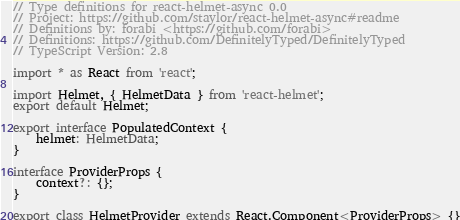<code> <loc_0><loc_0><loc_500><loc_500><_TypeScript_>// Type definitions for react-helmet-async 0.0
// Project: https://github.com/staylor/react-helmet-async#readme
// Definitions by: forabi <https://github.com/forabi>
// Definitions: https://github.com/DefinitelyTyped/DefinitelyTyped
// TypeScript Version: 2.8

import * as React from 'react';

import Helmet, { HelmetData } from 'react-helmet';
export default Helmet;

export interface PopulatedContext {
    helmet: HelmetData;
}

interface ProviderProps {
    context?: {};
}

export class HelmetProvider extends React.Component<ProviderProps> {}
</code> 